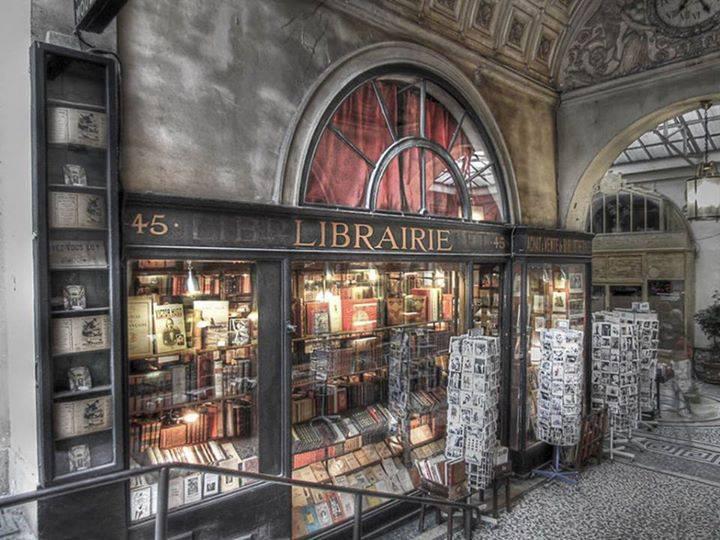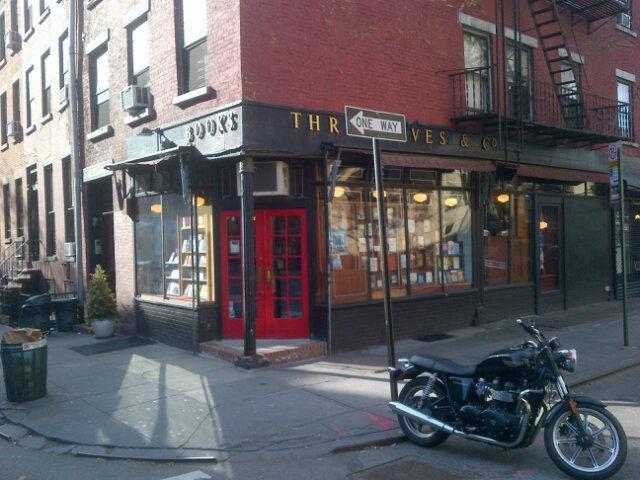The first image is the image on the left, the second image is the image on the right. Given the left and right images, does the statement "A single two-wheeled vehicle is parked in front of a shop with red double doors." hold true? Answer yes or no. Yes. The first image is the image on the left, the second image is the image on the right. For the images displayed, is the sentence "The building on the right image has a closed red door while the building on the other side does not." factually correct? Answer yes or no. Yes. 